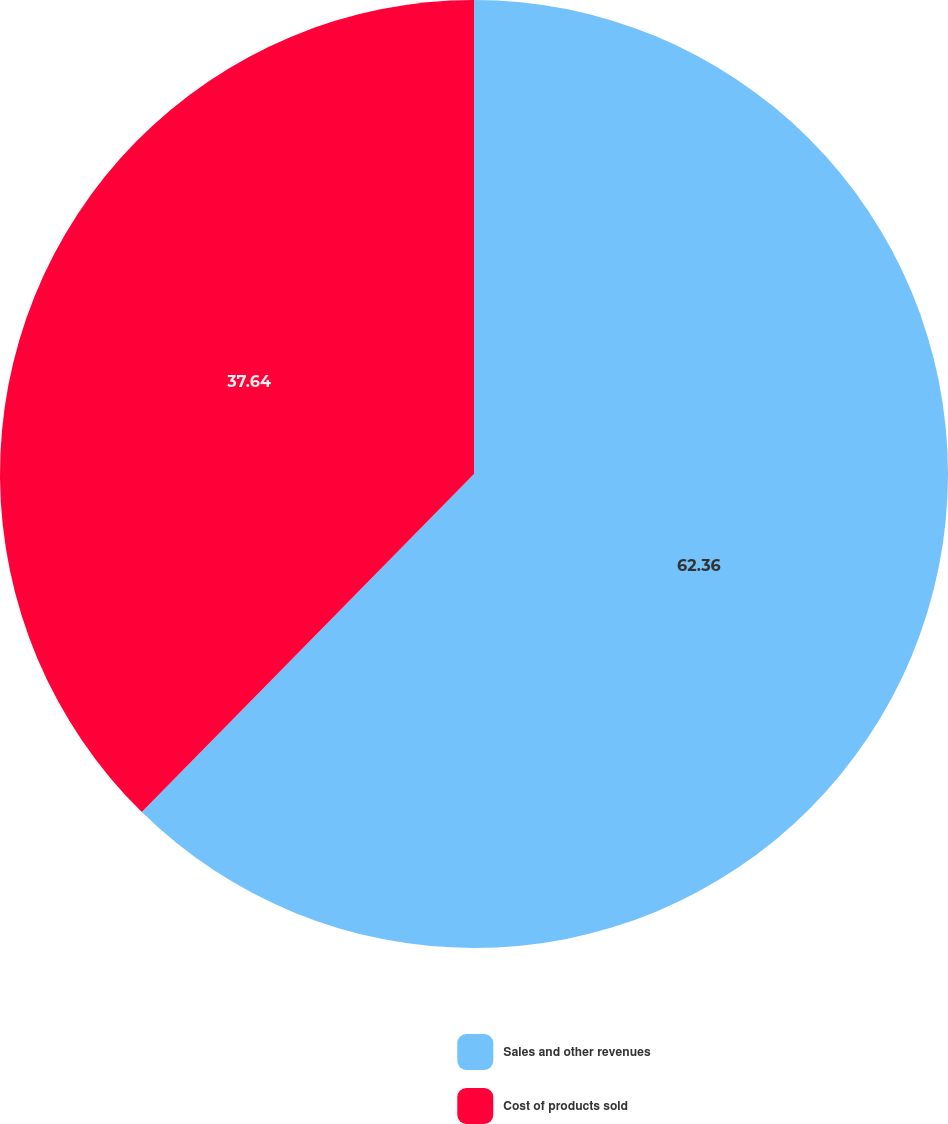Convert chart to OTSL. <chart><loc_0><loc_0><loc_500><loc_500><pie_chart><fcel>Sales and other revenues<fcel>Cost of products sold<nl><fcel>62.36%<fcel>37.64%<nl></chart> 